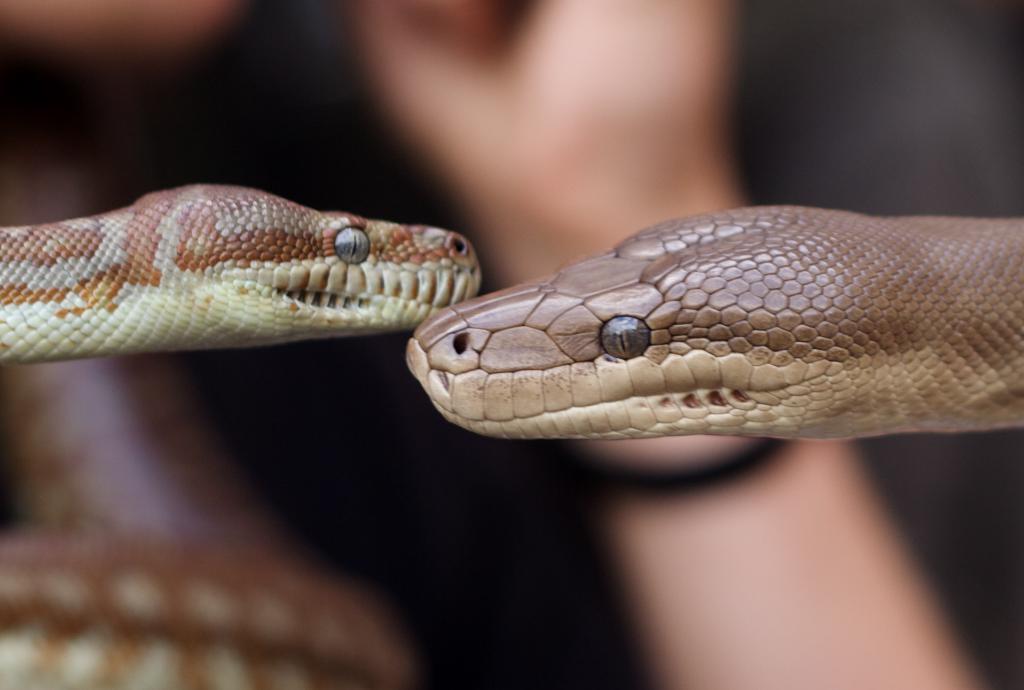Can you describe this image briefly? In this image we can see snakes. In the background there is a person. 